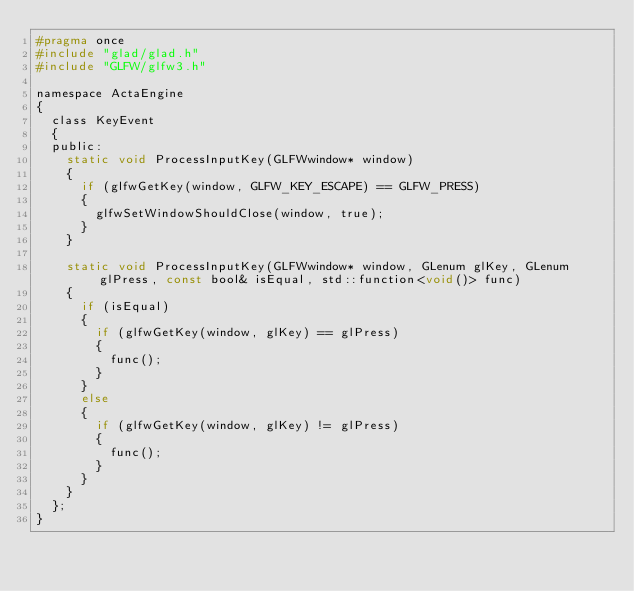Convert code to text. <code><loc_0><loc_0><loc_500><loc_500><_C_>#pragma once
#include "glad/glad.h"
#include "GLFW/glfw3.h"

namespace ActaEngine
{
	class KeyEvent
	{
	public:
		static void ProcessInputKey(GLFWwindow* window)
		{
			if (glfwGetKey(window, GLFW_KEY_ESCAPE) == GLFW_PRESS)
			{
				glfwSetWindowShouldClose(window, true);
			}
		}

		static void ProcessInputKey(GLFWwindow* window, GLenum glKey, GLenum glPress, const bool& isEqual, std::function<void()> func)
		{
			if (isEqual)
			{
				if (glfwGetKey(window, glKey) == glPress)
				{
					func();
				}
			}
			else
			{
				if (glfwGetKey(window, glKey) != glPress)
				{
					func();
				}
			}
		}
	};
}</code> 